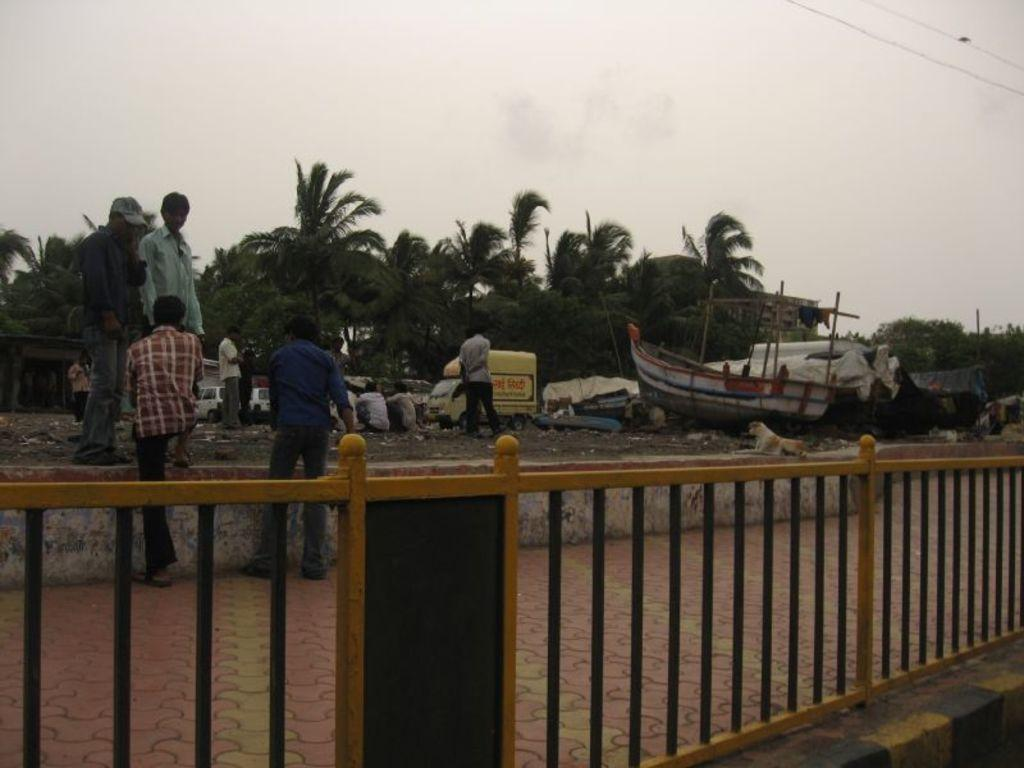How many people are present in the image? There are people in the image, but the exact number is not specified. What types of vehicles can be seen in the image? There are vehicles in the image, but the specific types are not mentioned. What is the boat's location in the image? The boat is in the image, but its exact location is not specified. What animal is present in the image? There is a dog in the image. What color objects can be seen in the image? There are white color objects in the image. What type of structure is present in the image? There is a building in the image. What type of vegetation is present in the image? There are trees in the image. What type of barrier is present in the image? There is a fence in the image. What type of infrastructure is present in the image? There are cables in the image. What part of the natural environment is visible in the image? The sky is visible in the image. Where is the pen located in the image? There is no pen present in the image. What type of shop can be seen in the image? There is no shop present in the image. What is the position of the sun in the image? The sun is not visible in the image; only the sky is visible. 